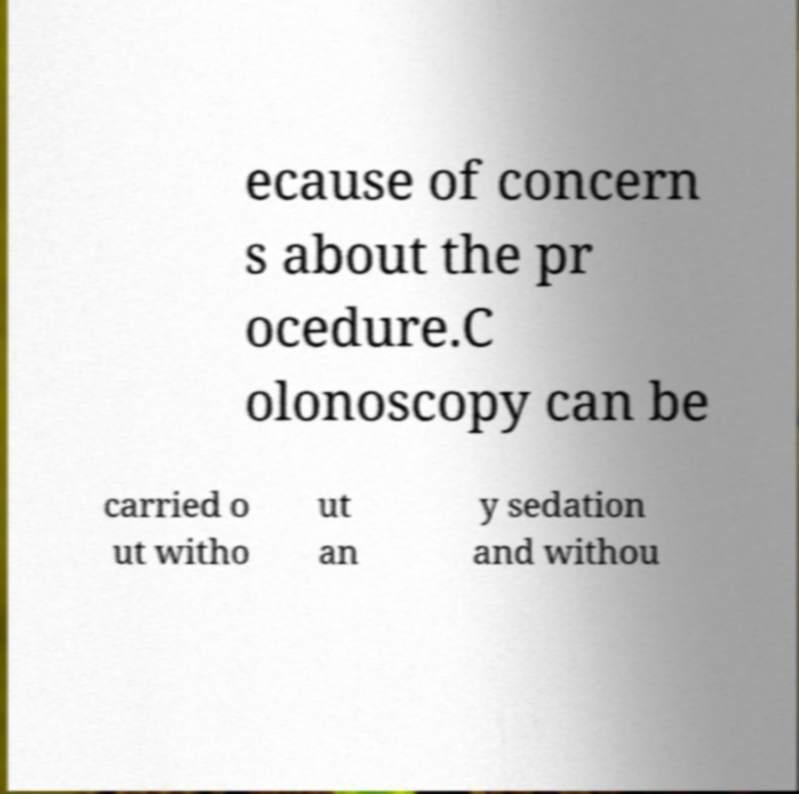I need the written content from this picture converted into text. Can you do that? ecause of concern s about the pr ocedure.C olonoscopy can be carried o ut witho ut an y sedation and withou 